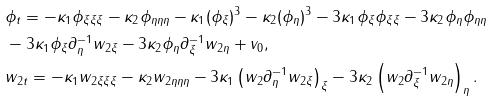<formula> <loc_0><loc_0><loc_500><loc_500>& \phi _ { t } = - \kappa _ { 1 } \phi _ { \xi \xi \xi } - \kappa _ { 2 } \phi _ { \eta \eta \eta } - \kappa _ { 1 } ( \phi _ { \xi } ) ^ { 3 } - \kappa _ { 2 } ( \phi _ { \eta } ) ^ { 3 } - 3 \kappa _ { 1 } \phi _ { \xi } \phi _ { \xi \xi } - 3 \kappa _ { 2 } \phi _ { \eta } \phi _ { \eta \eta } \\ & - 3 \kappa _ { 1 } \phi _ { \xi } \partial _ { \eta } ^ { - 1 } w _ { 2 \xi } - 3 \kappa _ { 2 } \phi _ { \eta } \partial _ { \xi } ^ { - 1 } w _ { 2 \eta } + v _ { 0 } , \\ & w _ { 2 t } = - \kappa _ { 1 } w _ { 2 \xi \xi \xi } - \kappa _ { 2 } w _ { 2 \eta \eta \eta } - 3 \kappa _ { 1 } \left ( w _ { 2 } \partial _ { \eta } ^ { - 1 } w _ { 2 \xi } \right ) _ { \xi } - 3 \kappa _ { 2 } \left ( w _ { 2 } \partial _ { \xi } ^ { - 1 } w _ { 2 \eta } \right ) _ { \eta } .</formula> 